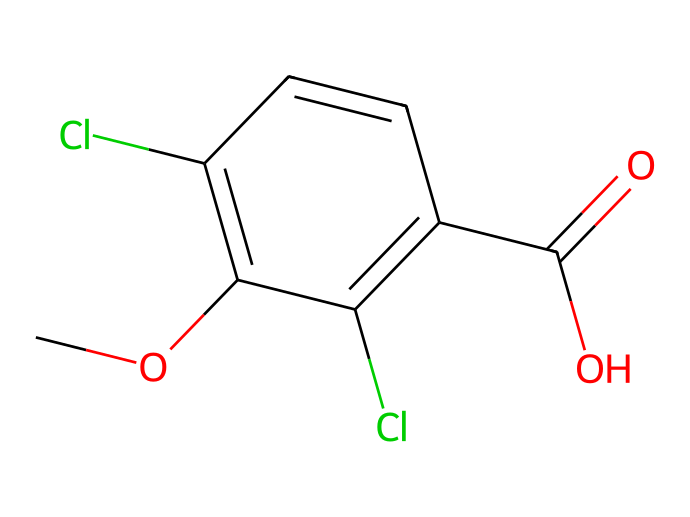What is the base structure of dicamba? The chemical structure shows a benzene ring which is common in auxin-type herbicides. The presence of substituents confirms it as a modified aromatic compound.
Answer: benzene ring How many chlorine atoms are present in dicamba? The SMILES representation indicates two 'Cl' notations, showing two chlorine substituents attached to the aromatic ring.
Answer: two What functional group is part of dicamba's structure? The 'C(=O)O' portion signifies the presence of a carboxylic acid functional group, which is characteristic of many herbicides.
Answer: carboxylic acid Which type of herbicide is dicamba classified as? The structure reveals the presence of an auxin-like configuration, indicated by the benzene ring and carboxylic acid, thus classifying it as an auxin-type herbicide.
Answer: auxin-type herbicide What effect does the presence of chlorine atoms have on dicamba? The chlorine atoms typically increase the herbicidal activity and metabolic stability of the compound, as they can affect the chemical's reactivity and solubility.
Answer: increases activity How many total carbon atoms are there in dicamba? By counting the carbon atoms in the SMILES string, there are a total of six carbons in the aromatic ring and one in the carboxylic acid, leading to a total of seven.
Answer: seven 